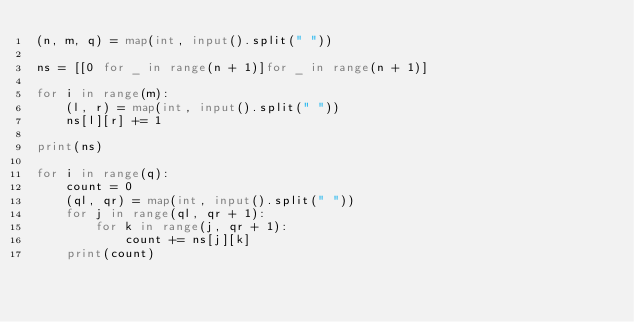Convert code to text. <code><loc_0><loc_0><loc_500><loc_500><_Python_>(n, m, q) = map(int, input().split(" "))

ns = [[0 for _ in range(n + 1)]for _ in range(n + 1)]

for i in range(m):
    (l, r) = map(int, input().split(" "))
    ns[l][r] += 1

print(ns)

for i in range(q):
    count = 0
    (ql, qr) = map(int, input().split(" "))
    for j in range(ql, qr + 1):
        for k in range(j, qr + 1):
            count += ns[j][k]
    print(count)
</code> 